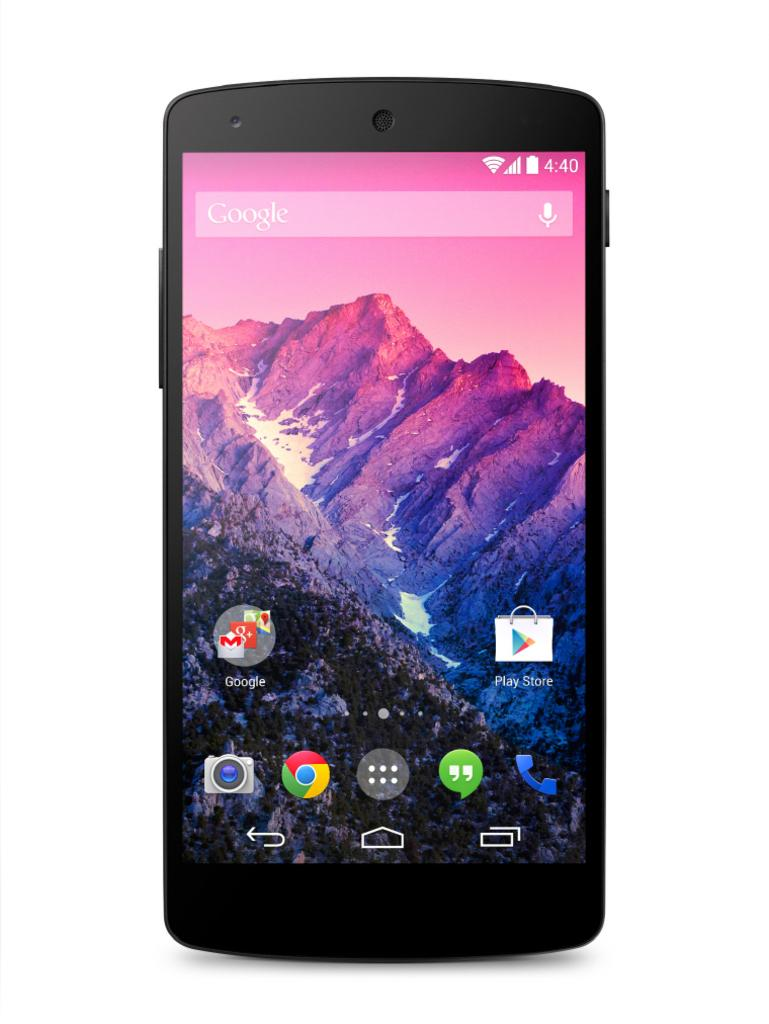What object is the main subject of the image? There is a mobile in the image. What is the color of the mobile? The mobile is black in color. What can be seen on the mobile screen? There are icons visible on the mobile screen, including a mountain and the sky. What is the background color of the image? The background of the image is white. What type of pancake is being served on the mobile screen? There is no pancake present on the mobile screen; it displays icons, a mountain, and the sky. Can you tell me how many buttons are visible on the mobile screen? There is no mention of buttons on the mobile screen in the provided facts. What color is the orange on the mobile screen? There is no orange present on the mobile screen; it displays icons, a mountain, and the sky. 